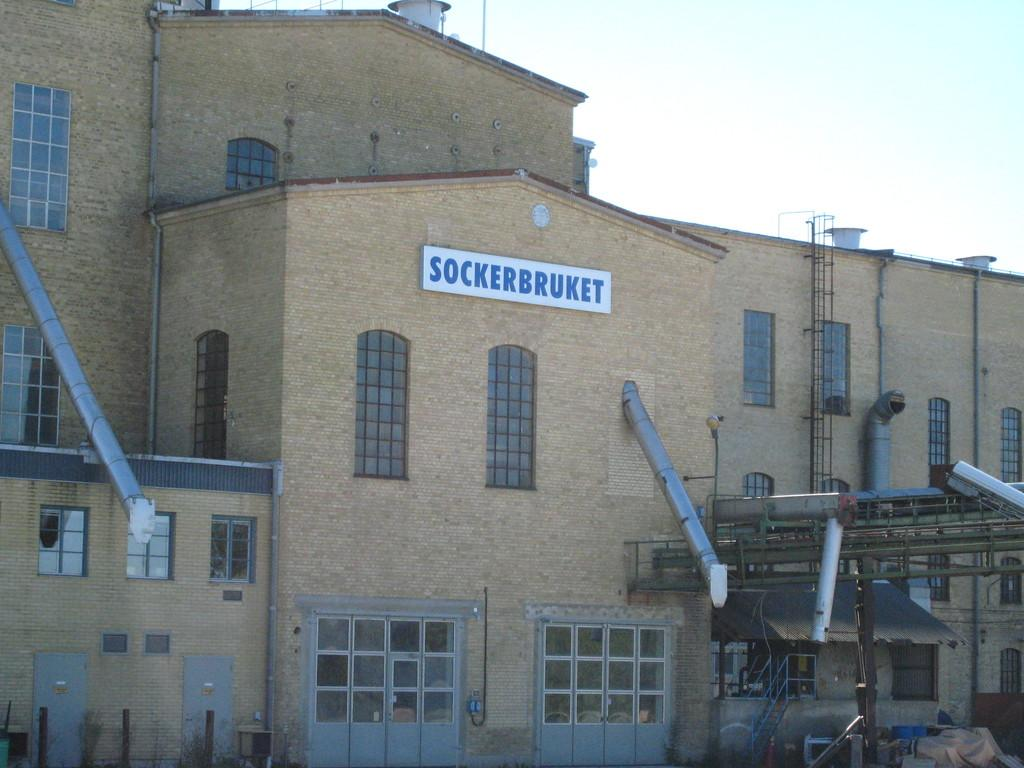What is the main structure in the image? There is a building in the image. What can be seen on the building? The building has pipes and other things. What is visible in the background of the image? There is a sky visible behind the building. What type of prose can be heard coming from the building in the image? There is no indication in the image that any prose is being spoken or heard, as the image only shows a building with pipes and other things. 